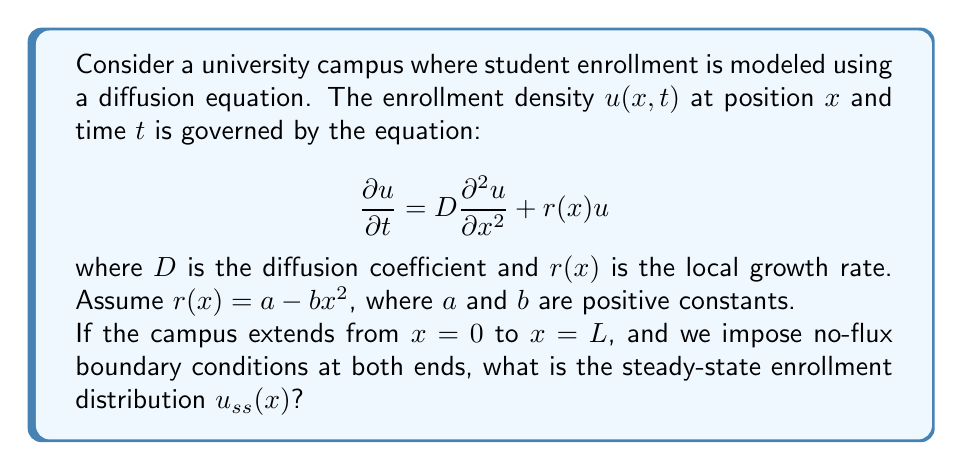Provide a solution to this math problem. To solve this problem, we'll follow these steps:

1) For steady-state, $\frac{\partial u}{\partial t} = 0$, so our equation becomes:

   $$D\frac{d^2 u_{ss}}{dx^2} + (a - bx^2)u_{ss} = 0$$

2) This is a second-order linear differential equation. We can rewrite it as:

   $$\frac{d^2 u_{ss}}{dx^2} + \frac{a - bx^2}{D}u_{ss} = 0$$

3) This equation is similar to the time-independent Schrödinger equation for a quantum harmonic oscillator. Its solution is of the form:

   $$u_{ss}(x) = A \exp(-\frac{\sqrt{b}}{2\sqrt{D}}x^2)H_n(\frac{\sqrt[4]{b}}{\sqrt[4]{D}}x)$$

   where $H_n$ is the $n$-th Hermite polynomial and $A$ is a normalization constant.

4) The lowest energy state (ground state) corresponds to $n=0$, and $H_0(x) = 1$. This gives us:

   $$u_{ss}(x) = A \exp(-\frac{\sqrt{b}}{2\sqrt{D}}x^2)$$

5) For this to be a solution, it must satisfy the original equation. Substituting back:

   $$D(-\frac{\sqrt{b}}{\sqrt{D}}x + \frac{b}{D}x^3)u_{ss} + (a - bx^2)u_{ss} = 0$$

   $$(-\sqrt{bD}x + bx^3) + (a - bx^2) = 0$$

6) For this to be true for all $x$, we must have:

   $$a = \sqrt{bD}$$

7) The no-flux boundary conditions require $\frac{du_{ss}}{dx} = 0$ at $x=0$ and $x=L$. The condition at $x=0$ is automatically satisfied. For $x=L$:

   $$\frac{du_{ss}}{dx} = -A\frac{\sqrt{b}}{\sqrt{D}}L\exp(-\frac{\sqrt{b}}{2\sqrt{D}}L^2) = 0$$

   This is satisfied only if $L \to \infty$, which means the solution is an approximation for large $L$.

Therefore, the steady-state solution is:

$$u_{ss}(x) = A \exp(-\frac{\sqrt{b}}{2\sqrt{D}}x^2)$$

where $A$ is a normalization constant and $a = \sqrt{bD}$.
Answer: $$u_{ss}(x) = A \exp(-\frac{\sqrt{b}}{2\sqrt{D}}x^2)$$
where $A$ is a normalization constant and $a = \sqrt{bD}$. 